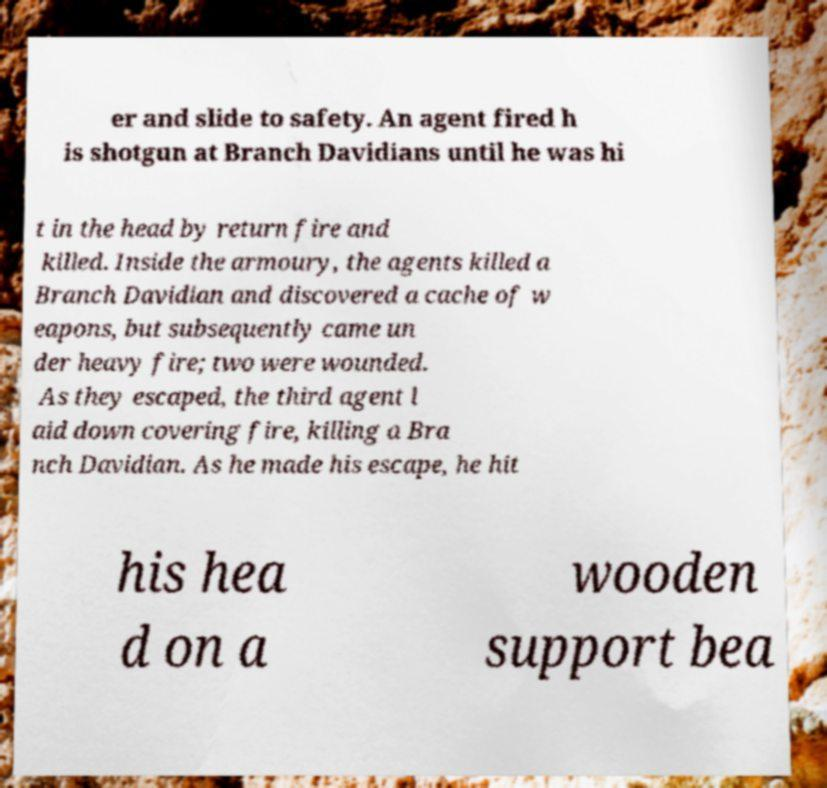Could you extract and type out the text from this image? er and slide to safety. An agent fired h is shotgun at Branch Davidians until he was hi t in the head by return fire and killed. Inside the armoury, the agents killed a Branch Davidian and discovered a cache of w eapons, but subsequently came un der heavy fire; two were wounded. As they escaped, the third agent l aid down covering fire, killing a Bra nch Davidian. As he made his escape, he hit his hea d on a wooden support bea 